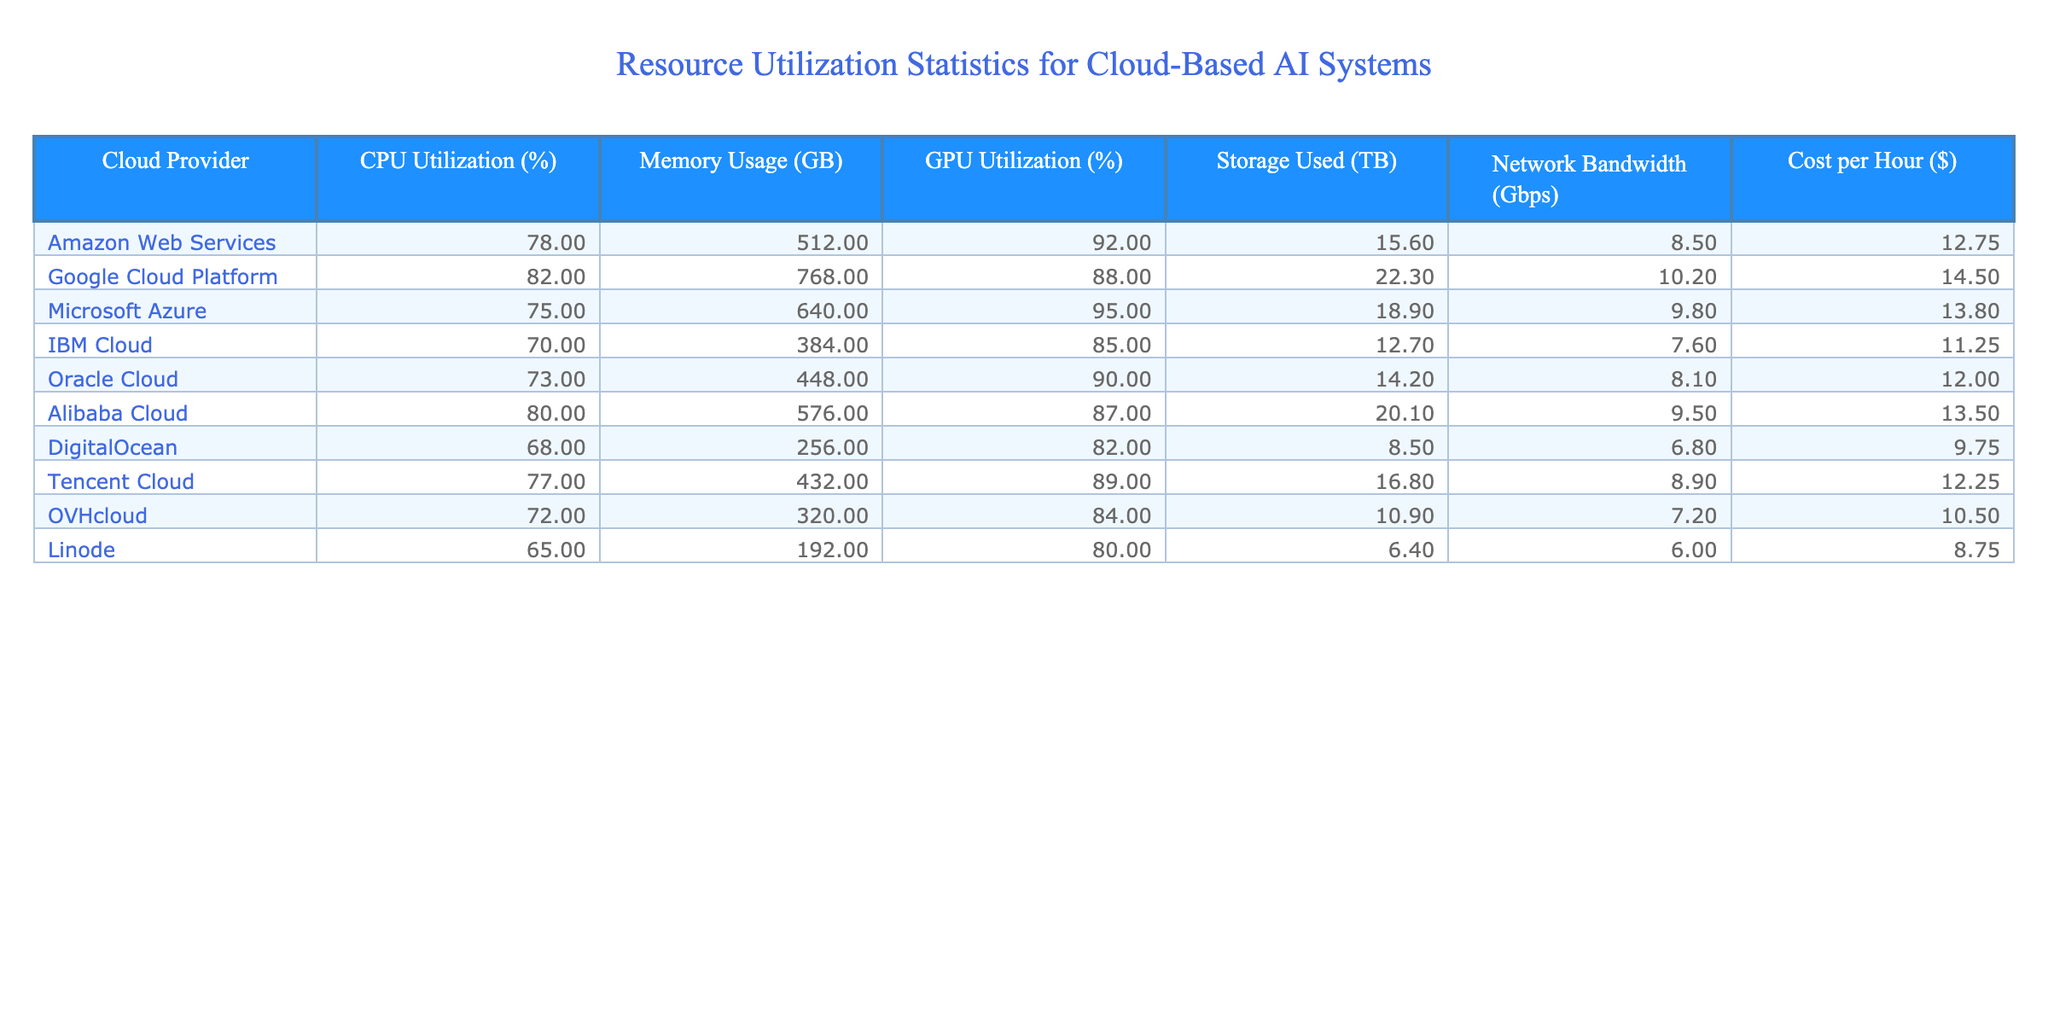What is the CPU utilization percentage for Google Cloud Platform? By looking at the table, the value in the row for Google Cloud Platform under the CPU Utilization column is 82%.
Answer: 82% Which cloud provider has the highest GPU utilization percentage? The GPU Utilization percentages for each provider are: AWS (92%), GCP (88%), Azure (95%), IBM (85%), Oracle (90%), Alibaba (87%), DigitalOcean (82%), Tencent (89%), OVH (84%), and Linode (80%). The highest among these is Microsoft Azure with 95%.
Answer: Microsoft Azure What is the average memory usage of all cloud providers? To find the average, we add up all the memory usage values: 512 + 768 + 640 + 384 + 448 + 576 + 256 + 432 + 320 + 192 = 4032 GB. There are 10 cloud providers, so the average is 4032 / 10 = 403.2 GB.
Answer: 403.2 GB Is the cost per hour for IBM Cloud less than $12? The cost per hour for IBM Cloud is $11.25, which is indeed less than $12.
Answer: Yes Which cloud providers have a storage usage of 15 TB or more? The storage used values are: AWS (15.6 TB), GCP (22.3 TB), Azure (18.9 TB), IBM (12.7 TB), Oracle (14.2 TB), Alibaba (20.1 TB), DigitalOcean (8.5 TB), Tencent (16.8 TB), OVH (10.9 TB), and Linode (6.4 TB). The providers with 15 TB or more are AWS, GCP, Azure, Alibaba, and Tencent.
Answer: AWS, GCP, Azure, Alibaba, Tencent How much does it cost per hour for the cloud provider with the lowest memory usage? DigitalOcean has the lowest memory usage of 256 GB. Its cost per hour is $9.75, as per the table.
Answer: $9.75 What is the difference in CPU utilization between Amazon Web Services and Oracle Cloud? CPU Utilization for AWS is 78% and for Oracle Cloud it's 73%. The difference is 78% - 73% = 5%.
Answer: 5% Identify the cloud provider with the lowest network bandwidth and state its value. The network bandwidth values are: AWS (8.5 Gbps), GCP (10.2 Gbps), Azure (9.8 Gbps), IBM (7.6 Gbps), Oracle (8.1 Gbps), Alibaba (9.5 Gbps), DigitalOcean (6.8 Gbps), Tencent (8.9 Gbps), OVH (7.2 Gbps), and Linode (6.0 Gbps). The lowest is DigitalOcean with 6.8 Gbps.
Answer: DigitalOcean, 6.8 Gbps What is the total storage used by all cloud providers combined? The total storage used is calculated by adding all values: 15.6 + 22.3 + 18.9 + 12.7 + 14.2 + 20.1 + 8.5 + 16.8 + 10.9 + 6.4 =  135.0 TB.
Answer: 135.0 TB Which cloud provider has the highest cost per hour, and what is that cost? By checking the cost per hour column, the values are: AWS ($12.75), GCP ($14.50), Azure ($13.80), IBM ($11.25), Oracle ($12.00), Alibaba ($13.50), DigitalOcean ($9.75), Tencent ($12.25), OVH ($10.50), Linode ($8.75). The highest cost is for Google Cloud Platform at $14.50.
Answer: Google Cloud Platform, $14.50 Are the average CPU and GPU utilizations across all providers more than 80%? The average CPU utilization is calculated by the sum: (78 + 82 + 75 + 70 + 73 + 80 + 68 + 77 + 72 + 65) / 10 = 75.8%. The average GPU utilization is (92 + 88 + 95 + 85 + 90 + 87 + 82 + 89 + 84 + 80) / 10 = 86.0%. The CPU utilization is less than 80% and the GPU utilization is more than 80%. Thus, the answer is mixed.
Answer: No for CPU, Yes for GPU 